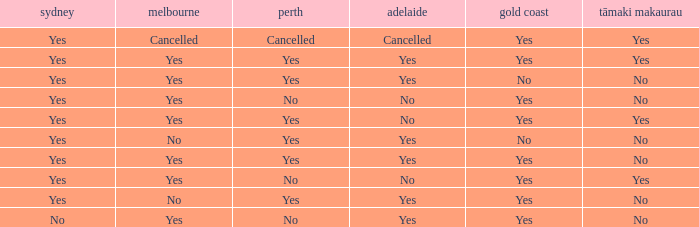What is The Melbourne with a No- Gold Coast Yes, No. 